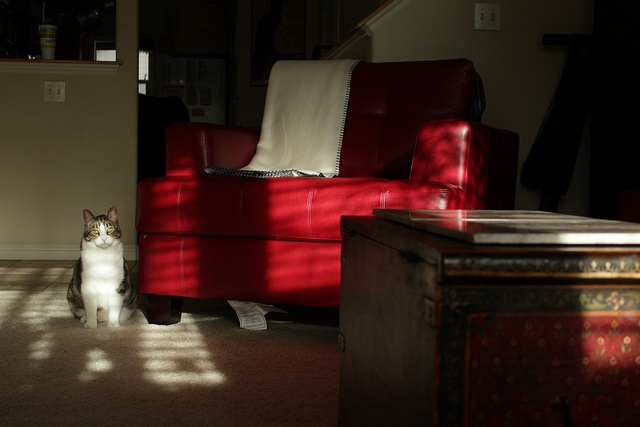Describe the objects in this image and their specific colors. I can see couch in black, brown, maroon, and gray tones, chair in black, brown, maroon, and gray tones, cat in black, ivory, gray, and darkgray tones, and cup in black and darkgreen tones in this image. 